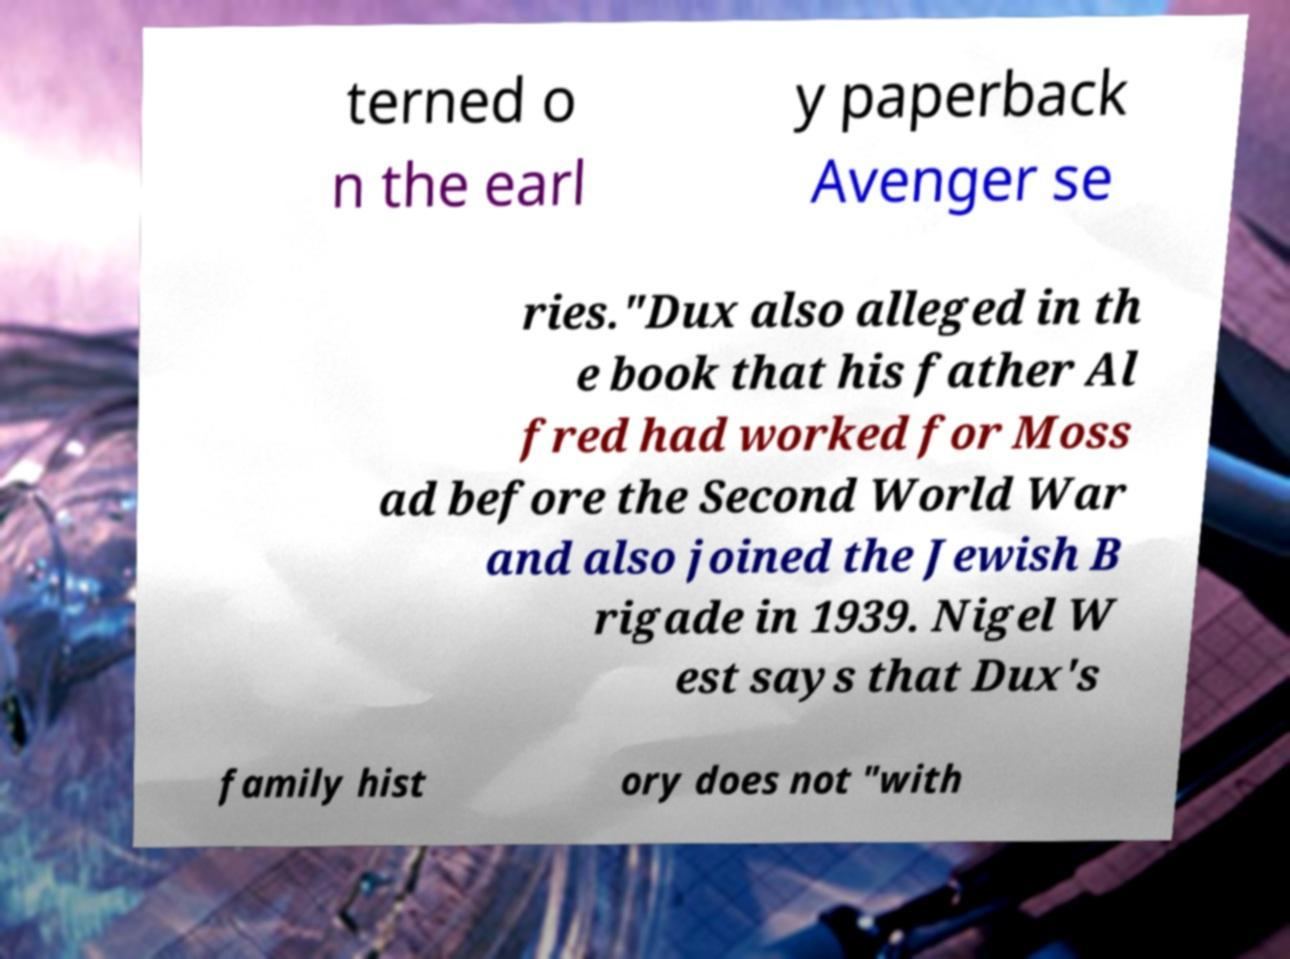Please read and relay the text visible in this image. What does it say? terned o n the earl y paperback Avenger se ries."Dux also alleged in th e book that his father Al fred had worked for Moss ad before the Second World War and also joined the Jewish B rigade in 1939. Nigel W est says that Dux's family hist ory does not "with 